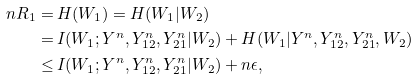<formula> <loc_0><loc_0><loc_500><loc_500>n R _ { 1 } = & \, H ( W _ { 1 } ) = H ( W _ { 1 } | W _ { 2 } ) \\ = & \, I ( W _ { 1 } ; Y ^ { n } , Y _ { 1 2 } ^ { n } , Y _ { 2 1 } ^ { n } | W _ { 2 } ) + H ( W _ { 1 } | Y ^ { n } , Y _ { 1 2 } ^ { n } , Y _ { 2 1 } ^ { n } , W _ { 2 } ) \\ \leq & \, I ( W _ { 1 } ; Y ^ { n } , Y _ { 1 2 } ^ { n } , Y _ { 2 1 } ^ { n } | W _ { 2 } ) + n \epsilon , \,</formula> 